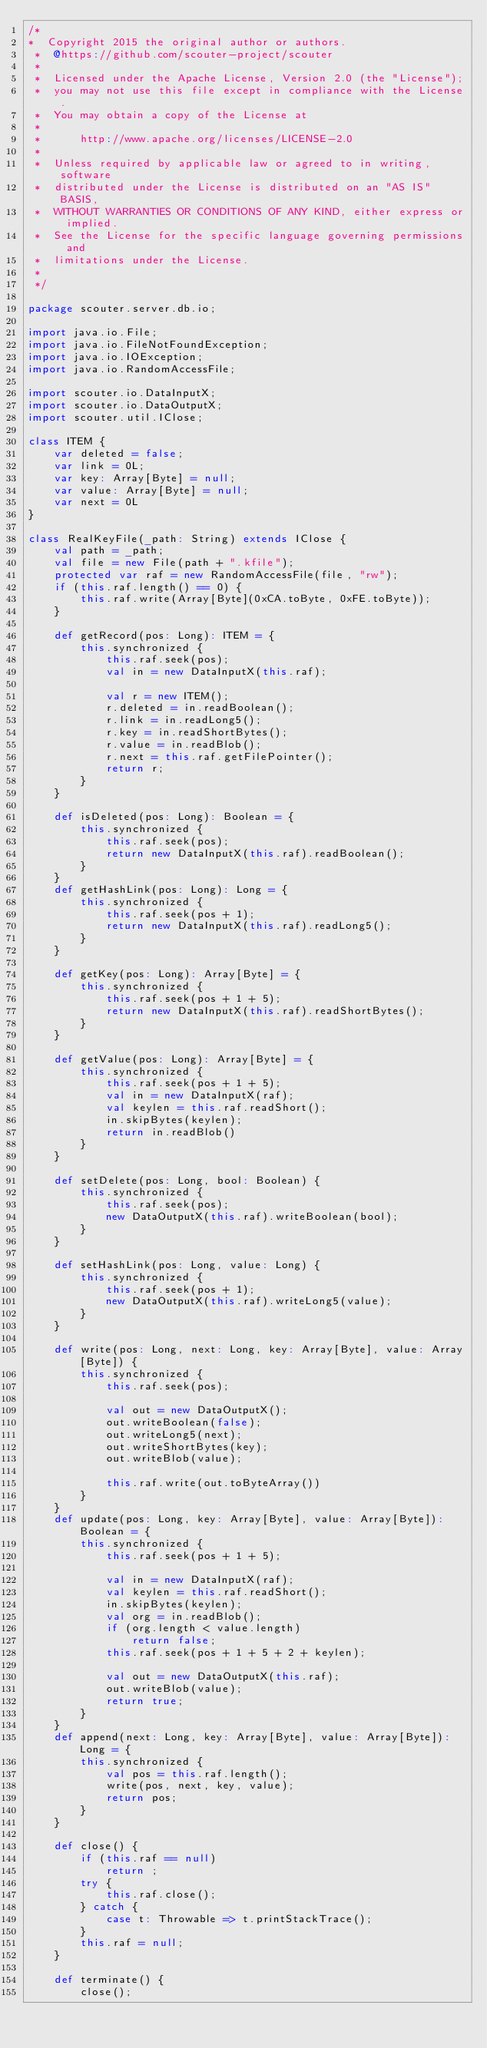Convert code to text. <code><loc_0><loc_0><loc_500><loc_500><_Scala_>/*
*  Copyright 2015 the original author or authors. 
 *  @https://github.com/scouter-project/scouter
 *
 *  Licensed under the Apache License, Version 2.0 (the "License"); 
 *  you may not use this file except in compliance with the License.
 *  You may obtain a copy of the License at
 *
 *      http://www.apache.org/licenses/LICENSE-2.0
 *
 *  Unless required by applicable law or agreed to in writing, software
 *  distributed under the License is distributed on an "AS IS" BASIS,
 *  WITHOUT WARRANTIES OR CONDITIONS OF ANY KIND, either express or implied.
 *  See the License for the specific language governing permissions and
 *  limitations under the License. 
 *
 */

package scouter.server.db.io;

import java.io.File;
import java.io.FileNotFoundException;
import java.io.IOException;
import java.io.RandomAccessFile;

import scouter.io.DataInputX;
import scouter.io.DataOutputX;
import scouter.util.IClose;

class ITEM {
    var deleted = false;
    var link = 0L;
    var key: Array[Byte] = null;
    var value: Array[Byte] = null;
    var next = 0L
}

class RealKeyFile(_path: String) extends IClose {
    val path = _path;
    val file = new File(path + ".kfile");
    protected var raf = new RandomAccessFile(file, "rw");
    if (this.raf.length() == 0) {
        this.raf.write(Array[Byte](0xCA.toByte, 0xFE.toByte));
    }

    def getRecord(pos: Long): ITEM = {
        this.synchronized {
            this.raf.seek(pos);
            val in = new DataInputX(this.raf);

            val r = new ITEM();
            r.deleted = in.readBoolean();
            r.link = in.readLong5();
            r.key = in.readShortBytes();
            r.value = in.readBlob();
            r.next = this.raf.getFilePointer();
            return r;
        }
    }

    def isDeleted(pos: Long): Boolean = {
        this.synchronized {
            this.raf.seek(pos);
            return new DataInputX(this.raf).readBoolean();
        }
    }
    def getHashLink(pos: Long): Long = {
        this.synchronized {
            this.raf.seek(pos + 1);
            return new DataInputX(this.raf).readLong5();
        }
    }

    def getKey(pos: Long): Array[Byte] = {
        this.synchronized {
            this.raf.seek(pos + 1 + 5);
            return new DataInputX(this.raf).readShortBytes();
        }
    }

    def getValue(pos: Long): Array[Byte] = {
        this.synchronized {
            this.raf.seek(pos + 1 + 5);
            val in = new DataInputX(raf);
            val keylen = this.raf.readShort();
            in.skipBytes(keylen);
            return in.readBlob()
        }
    }

    def setDelete(pos: Long, bool: Boolean) {
        this.synchronized {
            this.raf.seek(pos);
            new DataOutputX(this.raf).writeBoolean(bool);
        }
    }

    def setHashLink(pos: Long, value: Long) {
        this.synchronized {
            this.raf.seek(pos + 1);
            new DataOutputX(this.raf).writeLong5(value);
        }
    }

    def write(pos: Long, next: Long, key: Array[Byte], value: Array[Byte]) {
        this.synchronized {
            this.raf.seek(pos);
            
            val out = new DataOutputX();
            out.writeBoolean(false);
            out.writeLong5(next);
            out.writeShortBytes(key);
            out.writeBlob(value);
         
            this.raf.write(out.toByteArray())
        }
    }
    def update(pos: Long, key: Array[Byte], value: Array[Byte]): Boolean = {
        this.synchronized {
            this.raf.seek(pos + 1 + 5);
            
            val in = new DataInputX(raf);
            val keylen = this.raf.readShort();
            in.skipBytes(keylen);
            val org = in.readBlob();
            if (org.length < value.length)
                return false;
            this.raf.seek(pos + 1 + 5 + 2 + keylen);
            
            val out = new DataOutputX(this.raf);
            out.writeBlob(value);
            return true;
        }
    }
    def append(next: Long, key: Array[Byte], value: Array[Byte]): Long = {
        this.synchronized {
            val pos = this.raf.length();
            write(pos, next, key, value);
            return pos;
        }
    }

    def close() {
        if (this.raf == null)
            return ;
        try {
            this.raf.close();
        } catch {
            case t: Throwable => t.printStackTrace();
        }
        this.raf = null;
    }

    def terminate() {
        close();</code> 